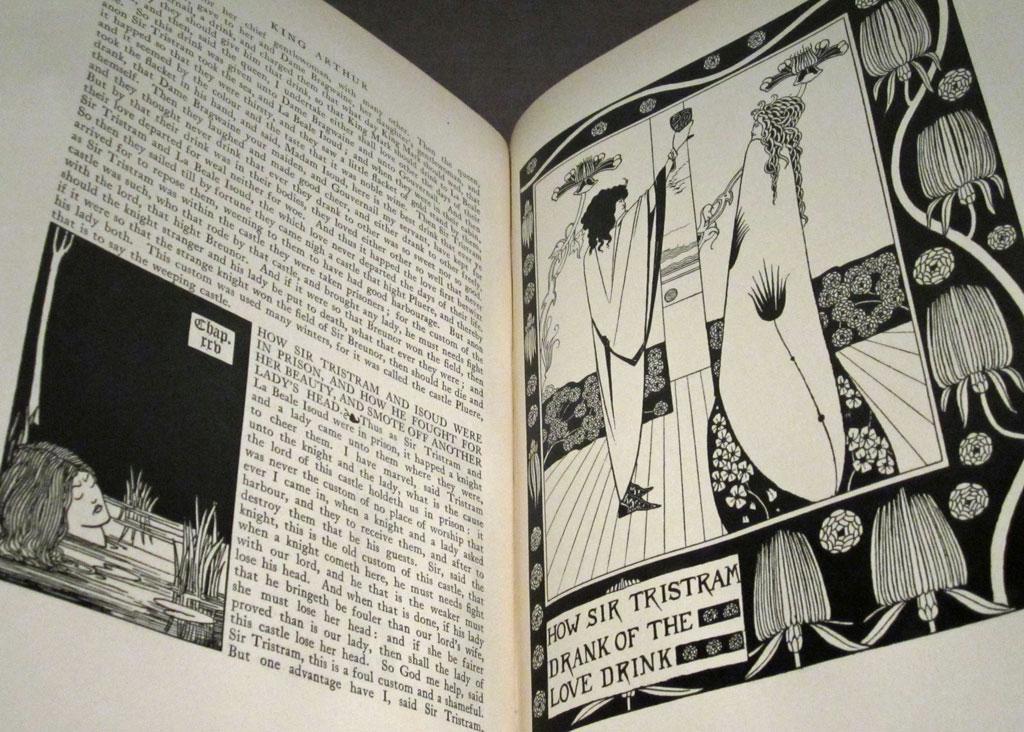What is the quote?
Offer a terse response. Unanswerable. What kind of drink?
Keep it short and to the point. Love. 